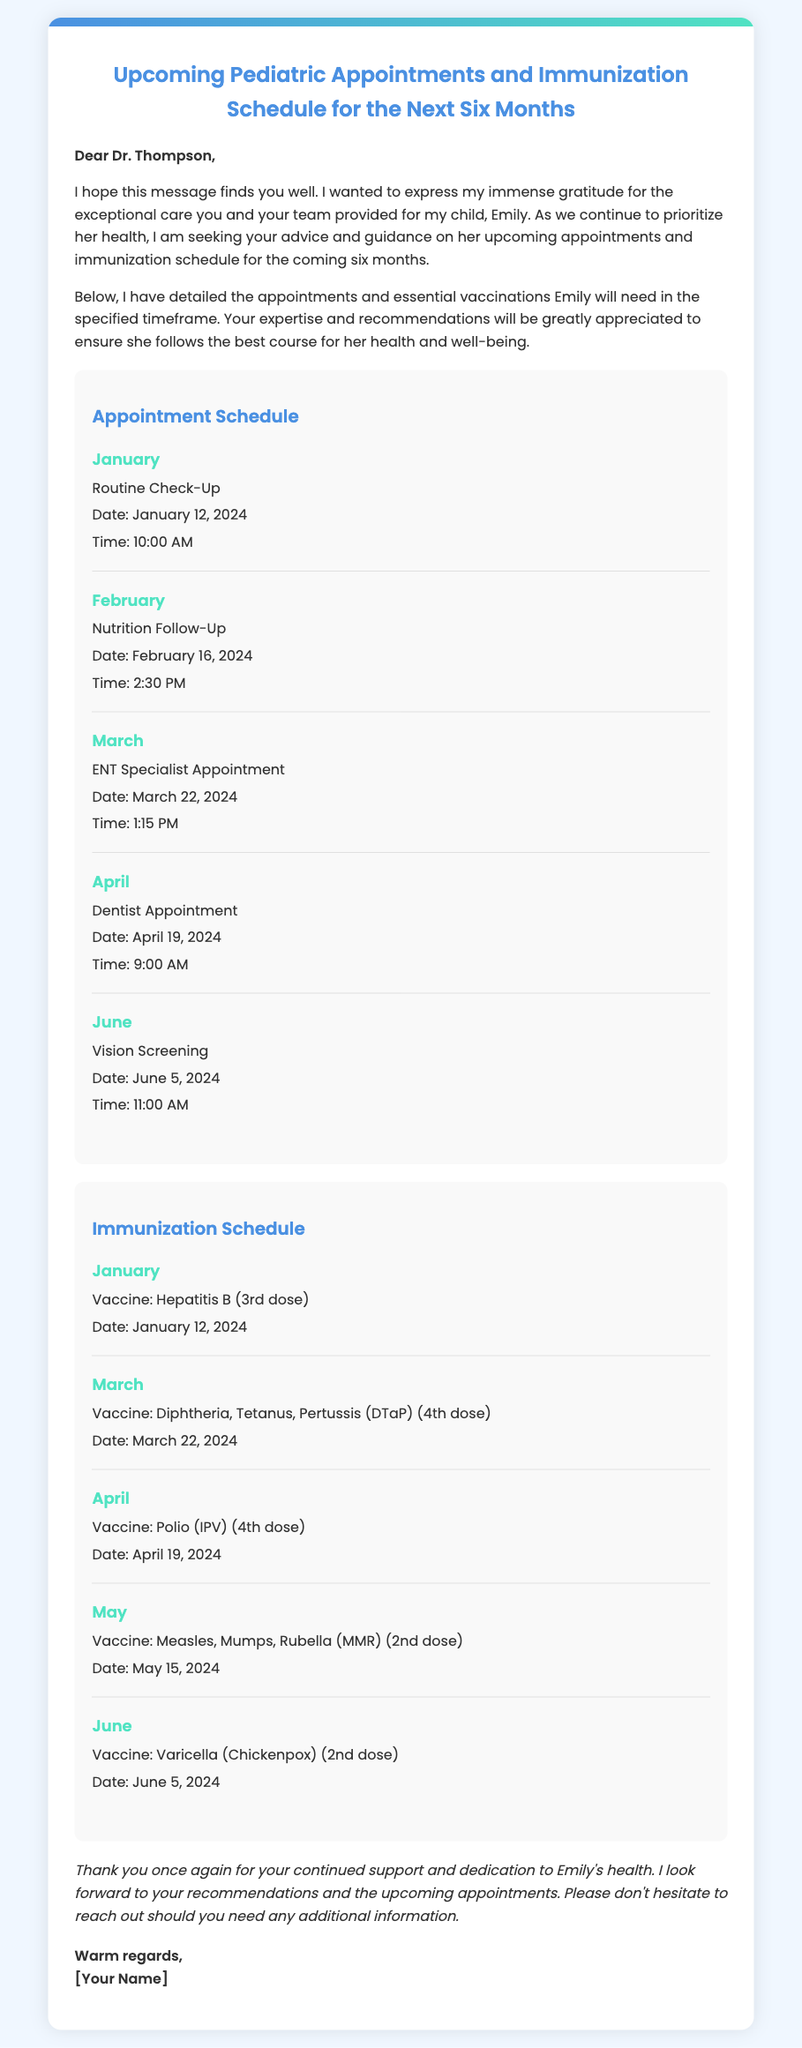What is the name of the child mentioned in the document? The name of the child is specifically referenced in the salutation and body text of the document.
Answer: Emily What is the date of the Routine Check-Up appointment? The specific date for the Routine Check-Up is found in the appointment schedule section.
Answer: January 12, 2024 How many immunizations are scheduled for June? The immunization schedule outlines the vaccines to be given in June.
Answer: One What medical specialty is the appointment in March related to? The document specifies the type of appointment scheduled for March in the appointment schedule section.
Answer: ENT Specialist What is the time for the nutrition follow-up appointment? The document provides the time for each scheduled appointment in the appointments section.
Answer: 2:30 PM Which vaccine is administered in May? The immunization schedule lists the vaccines along with their designated months.
Answer: Measles, Mumps, Rubella (MMR) (2nd dose) What month is the vision screening appointment scheduled for? The schedule clearly indicates the month for each appointment within the appointment schedule section.
Answer: June How many total appointments are listed in the document? The document contains several appointments, and counting them provides the total number.
Answer: Five What type of communication is this document? The document format and content indicate its purpose as a communication regarding health appointments.
Answer: Envelope 